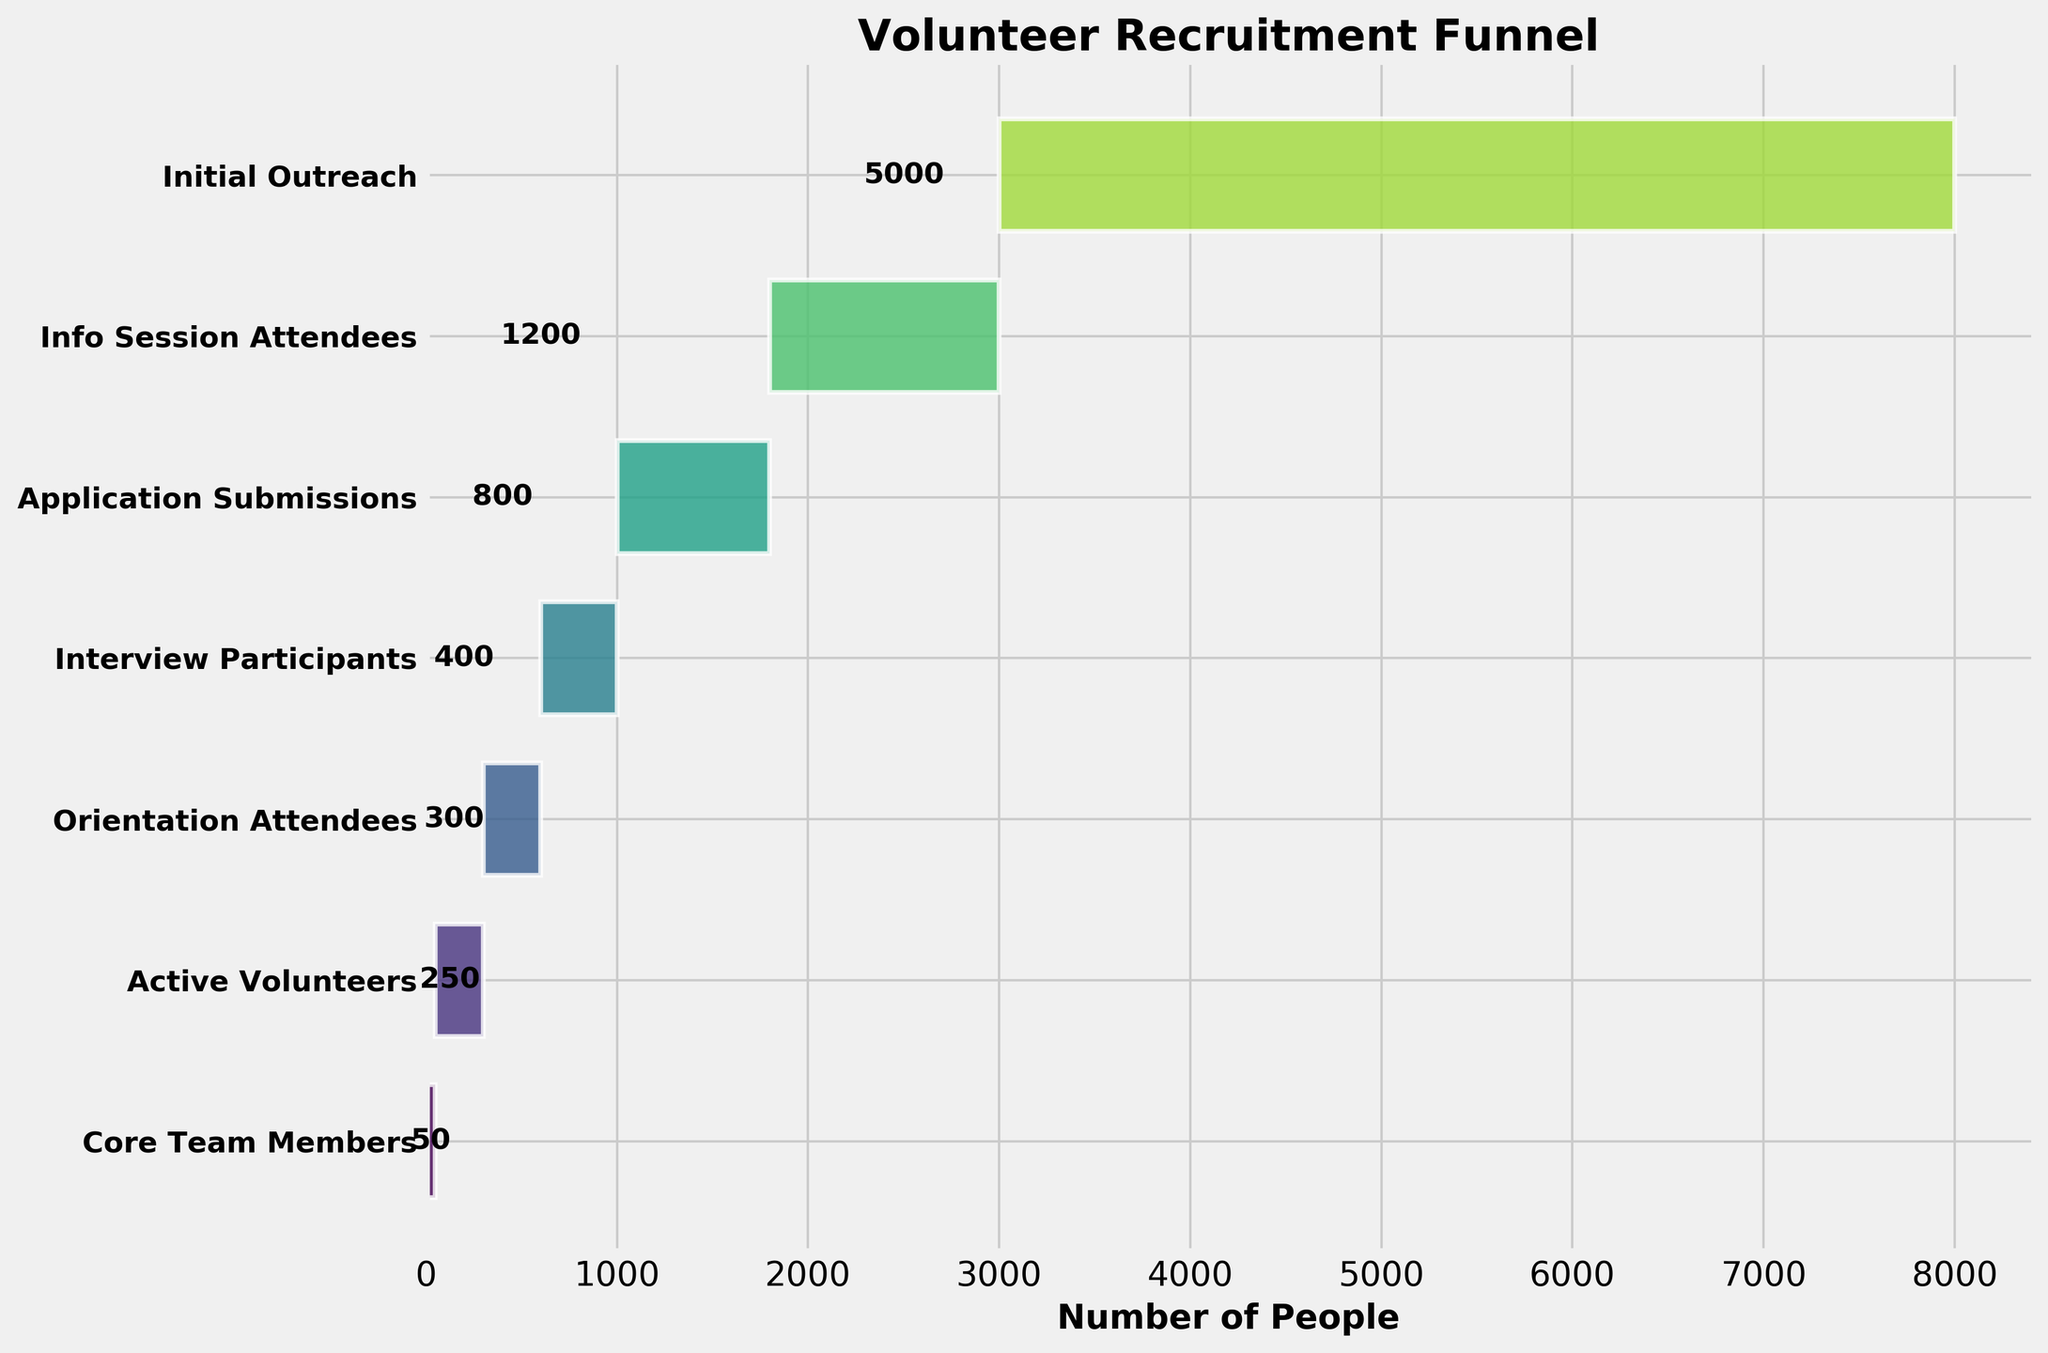How many stages are listed in the volunteer recruitment funnel? Count each unique stage name listed on the vertical axis in the plot. There are 7 stages listed.
Answer: 7 What is the difference in the number of people between the Initial Outreach stage and the Active Volunteers stage? Subtract the number of Active Volunteers from the number of people in the Initial Outreach stage. That is, \(5000 - 250\).
Answer: 4750 Which stage has the highest number of people? Identify the stage with the longest horizontal bar in the plot. The longest bar represents the Initial Outreach stage.
Answer: Initial Outreach What is the average number of people from Application Submissions to Core Team Members stages? Sum the values of the stages from Application Submissions to Core Team Members and divide by the number of these stages: \((800 + 400 + 300 + 250 + 50) / 5 = 360\).
Answer: 360 Which stage has exactly 50 people? Locate the bar labeled with '50' in the center and find its corresponding stage on the vertical axis. This stage is Core Team Members.
Answer: Core Team Members What percentage of Info Session Attendees become Active Volunteers? Divide the number of Active Volunteers by the number of Info Session Attendees and multiply by 100: \((250 / 1200) * 100\approx 20.83\%\).
Answer: 20.83% Is the number of Interview Participants greater than the number of Orientation Attendees? Compare the lengths of the bars for Interview Participants and Orientation Attendees. The bar for Interview Participants represents 400 people, while the bar for Orientation Attendees represents 300 people. Since 400 > 300, the comparison is valid.
Answer: Yes What is the total number of people involved from Info Session Attendees to Core Team Members? Add the numbers from Info Session Attendees to Core Team Members: \(1200 + 800 + 400 + 300 + 250 + 50 = 3000\).
Answer: 3000 What's the ratio of Initial Outreach to Core Team Members? Divide the number of people in Initial Outreach by the number of Core Team Members: \(5000 / 50 = 100\).
Answer: 100 How many stages see a decrease of more than 100 people compared to the previous stage? Examine each stage's number of people compared to its previous stage and see if the difference is greater than 100. The decreases greater than 100 occur from Initial Outreach (5000) to Info Session Attendees (1200), and from Info Session Attendees (1200) to Application Submissions (800) and Interview Participants (400). Three stages meet this condition.
Answer: 3 